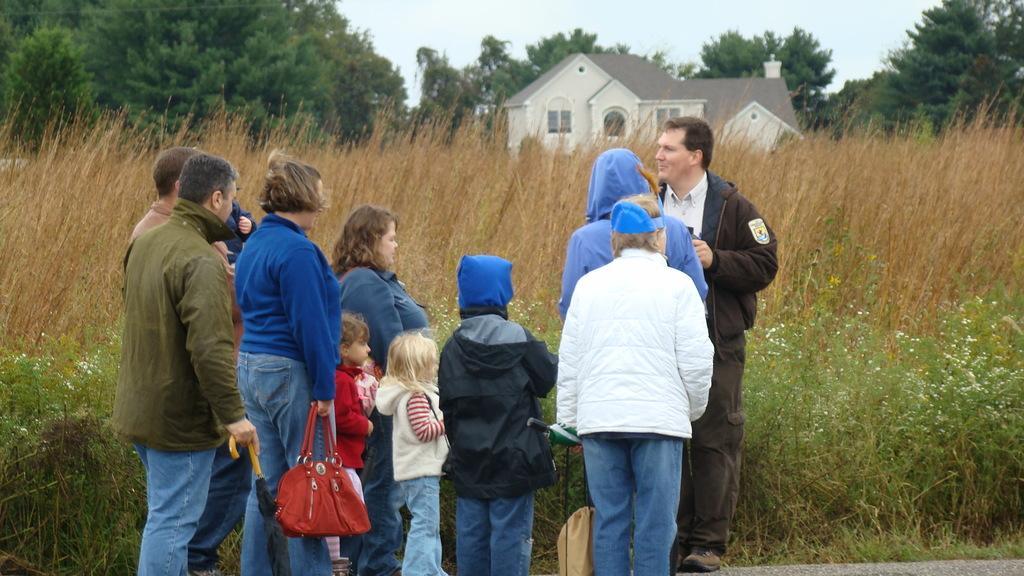How would you summarize this image in a sentence or two? In this image I can see the group of people with different color dresses. I can see few people are holding the caps and one person holding an umbrella. In the background I can see the plants, grass, house and many trees. I can also see the sky in the back. I can see the white color flowers to the plants. 